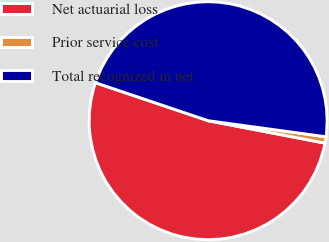Convert chart to OTSL. <chart><loc_0><loc_0><loc_500><loc_500><pie_chart><fcel>Net actuarial loss<fcel>Prior service cost<fcel>Total recognized in net<nl><fcel>52.16%<fcel>0.86%<fcel>46.98%<nl></chart> 